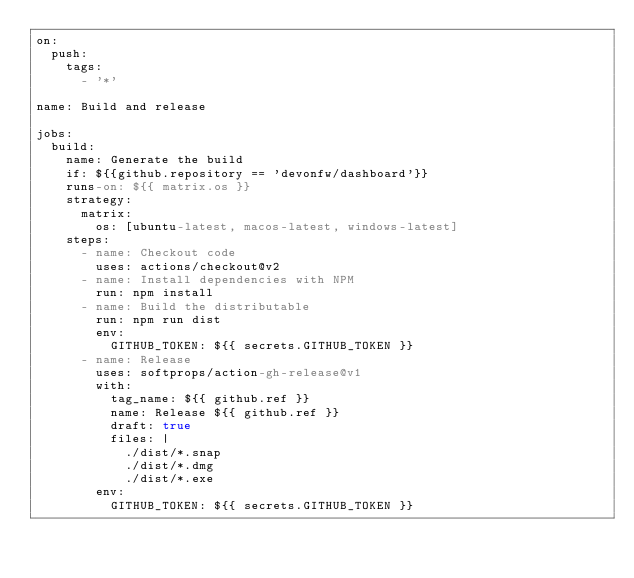Convert code to text. <code><loc_0><loc_0><loc_500><loc_500><_YAML_>on:
  push:
    tags:
      - '*'

name: Build and release

jobs:
  build:
    name: Generate the build
    if: ${{github.repository == 'devonfw/dashboard'}}
    runs-on: ${{ matrix.os }}
    strategy:
      matrix:
        os: [ubuntu-latest, macos-latest, windows-latest]
    steps:
      - name: Checkout code
        uses: actions/checkout@v2
      - name: Install dependencies with NPM
        run: npm install
      - name: Build the distributable
        run: npm run dist
        env:
          GITHUB_TOKEN: ${{ secrets.GITHUB_TOKEN }}
      - name: Release
        uses: softprops/action-gh-release@v1
        with:
          tag_name: ${{ github.ref }}
          name: Release ${{ github.ref }}
          draft: true
          files: |
            ./dist/*.snap
            ./dist/*.dmg
            ./dist/*.exe
        env:
          GITHUB_TOKEN: ${{ secrets.GITHUB_TOKEN }}
</code> 